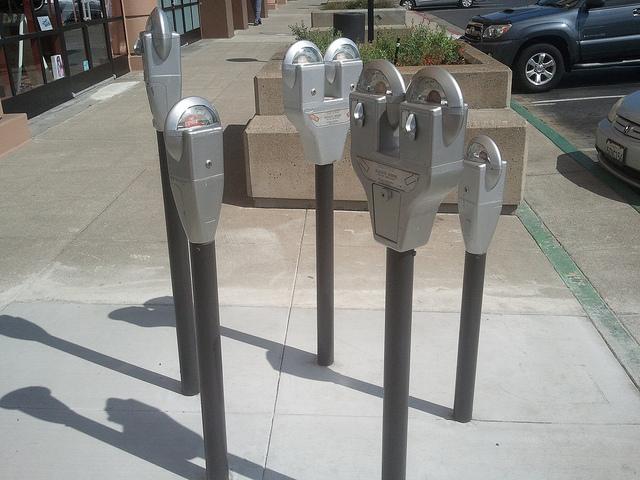How many parking meters are there?
Concise answer only. 5. How many parking meters are shown?
Short answer required. 5. What are these silver objects?
Concise answer only. Parking meters. Is there a blue car?
Quick response, please. Yes. 